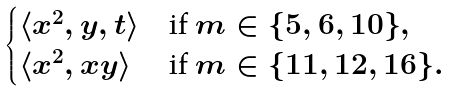Convert formula to latex. <formula><loc_0><loc_0><loc_500><loc_500>\begin{cases} \langle x ^ { 2 } , y , t \rangle & \text {if $m\in\{5,6,10\}$} , \\ \langle x ^ { 2 } , x y \rangle & \text {if $m\in\{11,12,16\}$} . \end{cases}</formula> 